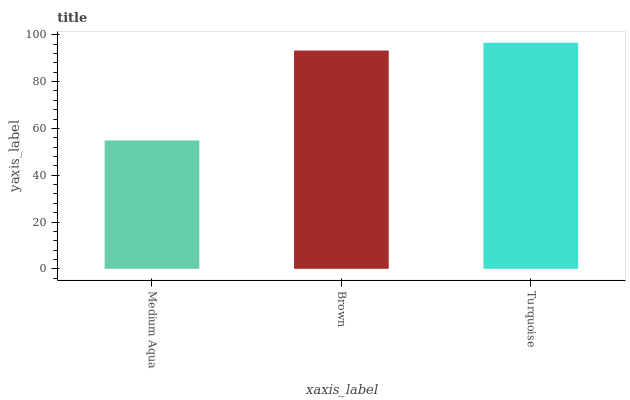Is Medium Aqua the minimum?
Answer yes or no. Yes. Is Turquoise the maximum?
Answer yes or no. Yes. Is Brown the minimum?
Answer yes or no. No. Is Brown the maximum?
Answer yes or no. No. Is Brown greater than Medium Aqua?
Answer yes or no. Yes. Is Medium Aqua less than Brown?
Answer yes or no. Yes. Is Medium Aqua greater than Brown?
Answer yes or no. No. Is Brown less than Medium Aqua?
Answer yes or no. No. Is Brown the high median?
Answer yes or no. Yes. Is Brown the low median?
Answer yes or no. Yes. Is Medium Aqua the high median?
Answer yes or no. No. Is Turquoise the low median?
Answer yes or no. No. 